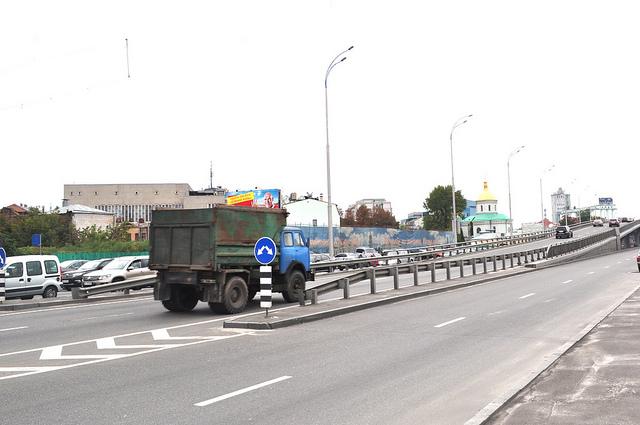What vehicles are in the pic?
Concise answer only. Cars. How many tracks are displayed?
Keep it brief. 0. Is this a rural location?
Give a very brief answer. No. Is traffic heavy on the right side of the road?
Answer briefly. No. Was this photo taken in the 21st century?
Give a very brief answer. Yes. What color is the street sign?
Write a very short answer. Blue. 